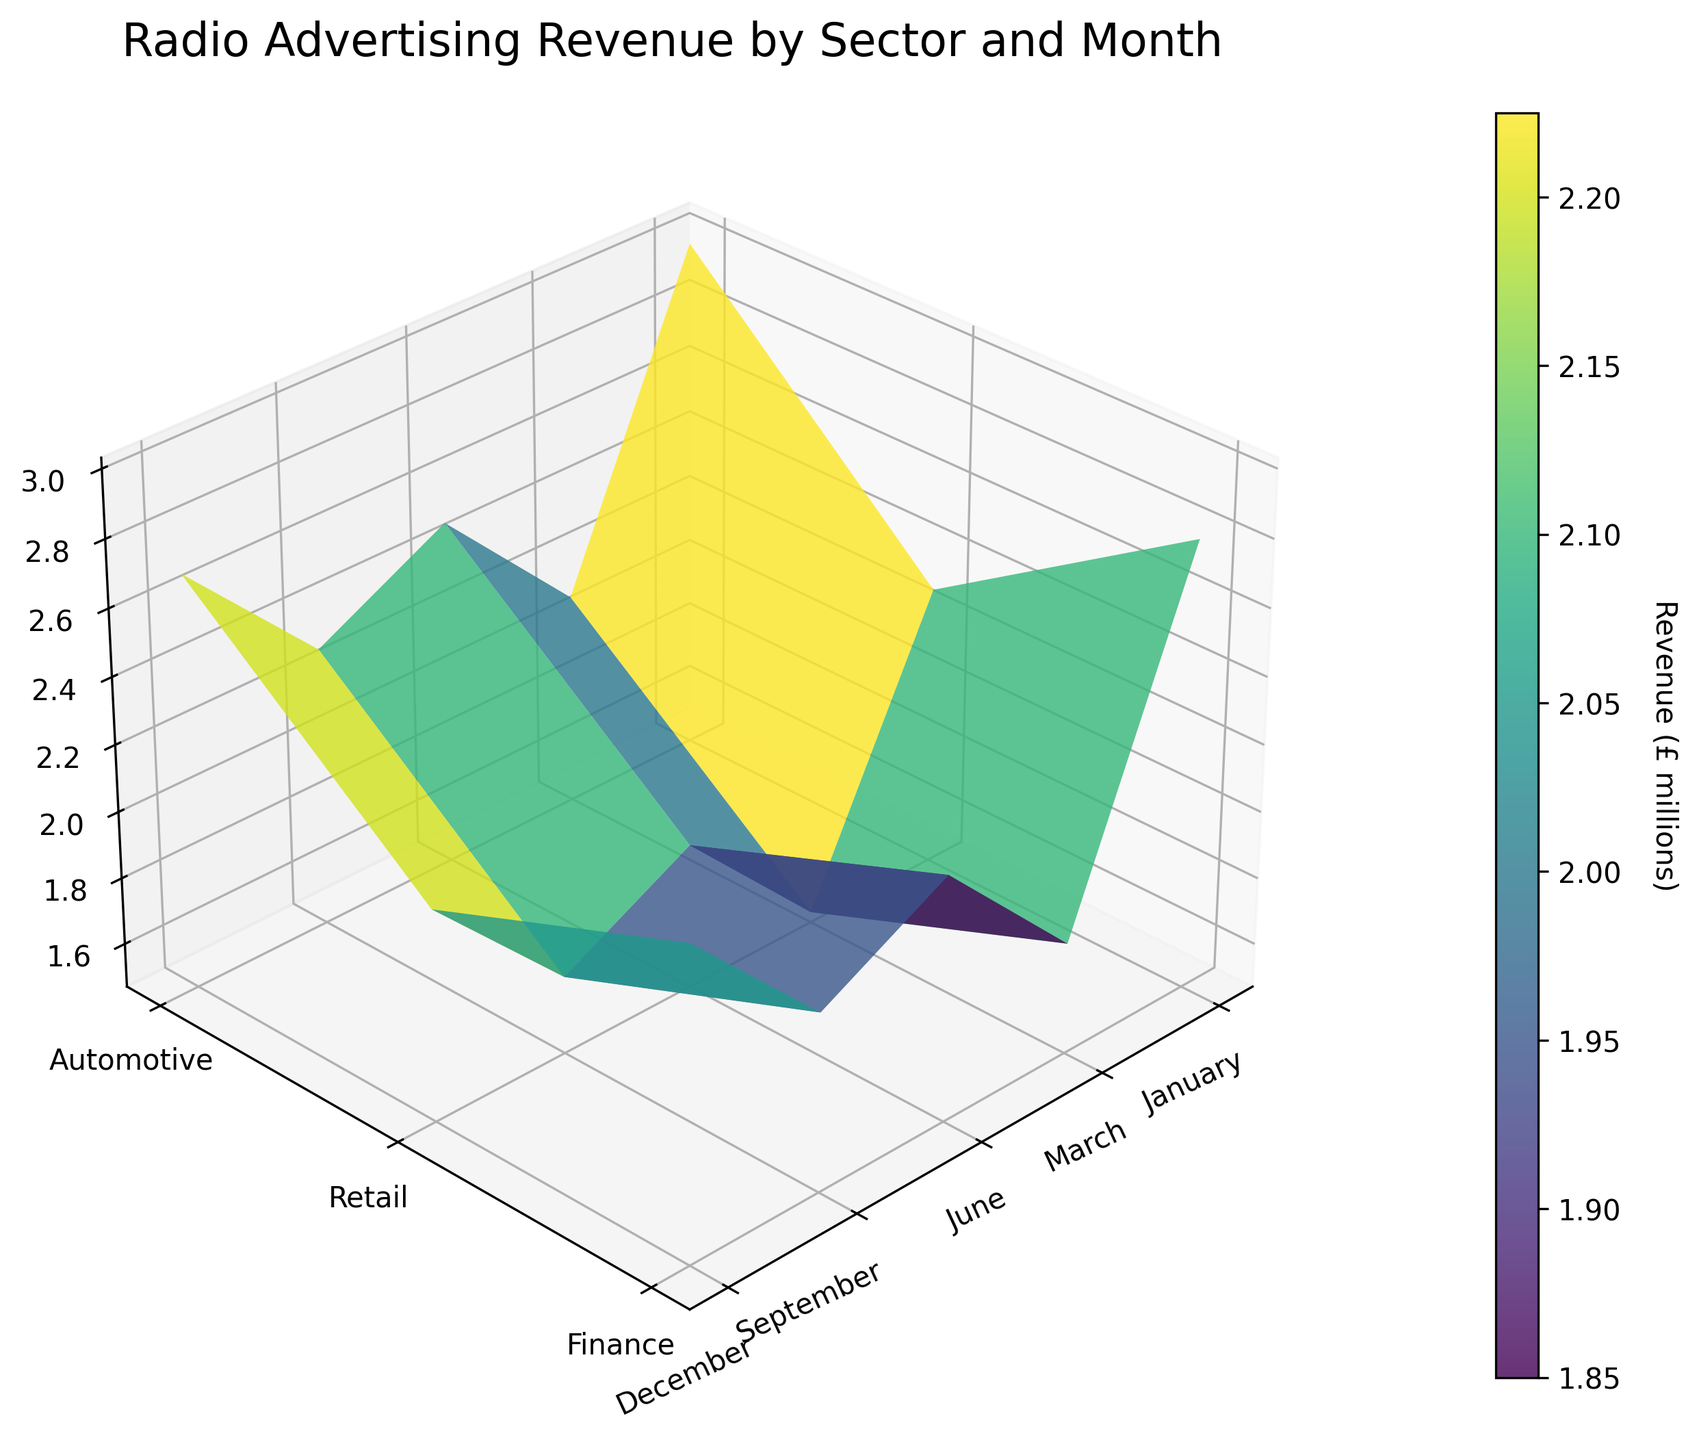How many months are displayed on the X-axis? The figure has ticks marked for each month on the X-axis, which are January, March, June, September, and December.
Answer: 5 Which sector has the highest revenue in December? By looking at the peak values on the surface plot for each sector in December, the Automotive sector has the highest revenue.
Answer: Automotive What is the approximate difference in revenue between the Automotive and Finance sectors in June? Identify the heights (revenue) for the Automotive and Finance sectors in June, which are 2.5 and 1.9 respectively, and subtract the smaller from the larger value: 2.5 - 1.9 = 0.6.
Answer: 0.6 In which month does the Retail sector have its highest revenue? By examining the peaks for the Retail sector across all months, the highest revenue is in December.
Answer: December What is the total revenue for all sectors combined in March? Find the revenue values for each sector in March (Automotive: 2.3, Retail: 2.0, Finance: 1.7) and sum them: 2.3 + 2.0 + 1.7 = 6.0.
Answer: 6.0 How does the Automotive sector's revenue trend from January to December? Observe the 3D surface plot’s progression in the Automotive sector from its starting point in January to its highest point in December. The revenue shows a consistent increase over the months.
Answer: Increasing Which sector shows the least variation in revenue throughout the year? Assess the fluctuation size of the surface plot for each sector; the Finance sector has the least variation in height across the months.
Answer: Finance If you average the revenues of the Retail sector in January and September, what do you get? The revenues of Retail in January and September are 1.8 and 2.4 respectively. Calculate their average by summing them and dividing by 2: (1.8 + 2.4) / 2 = 2.1.
Answer: 2.1 Which month shows the highest total revenue across all sectors? Adding up the revenues for all sectors in each month, December has the highest cumulative revenue with (3.0 for Automotive + 2.8 for Retail + 2.3 for Finance) yielding 8.1.
Answer: December 